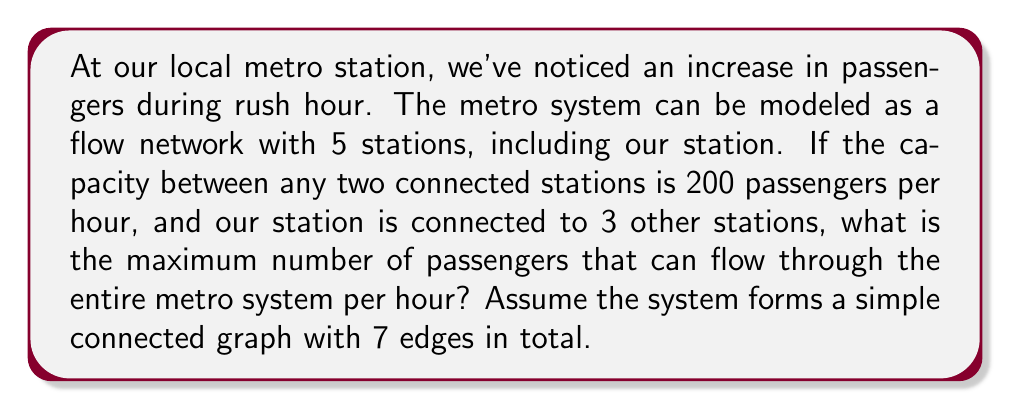Teach me how to tackle this problem. To solve this problem, we'll use the concept of maximum flow in a network. Here's a step-by-step approach:

1) First, let's visualize the metro system as a graph:
   [asy]
   unitsize(1cm);
   pair A=(0,0), B=(2,2), C=(4,0), D=(2,-2), E=(6,0);
   dot("A",A,W); dot("B",B,N); dot("C",C,N); dot("D",D,S); dot("E",E,E);
   draw(A--B--C--E);
   draw(A--D--C);
   draw(B--D);
   [/asy]

   Where our station is represented by node A.

2) We're told that our station (A) is connected to 3 other stations. This means A is connected to B, C, and D in our graph.

3) The total number of edges is 7, which matches our graph.

4) In a flow network, the maximum flow is limited by the minimum cut of the graph. In this case, the minimum cut would be the edges leaving the source (our station A) or entering the sink (let's assume E is the sink).

5) The capacity of each edge is 200 passengers per hour.

6) From our station A, there are 3 outgoing edges, each with a capacity of 200.

7) Therefore, the maximum flow out of A is:

   $$3 \times 200 = 600\text{ passengers per hour}$$

8) This is also the maximum flow for the entire system, as it's the bottleneck (the minimum cut) in the network.
Answer: The maximum number of passengers that can flow through the entire metro system per hour is 600. 